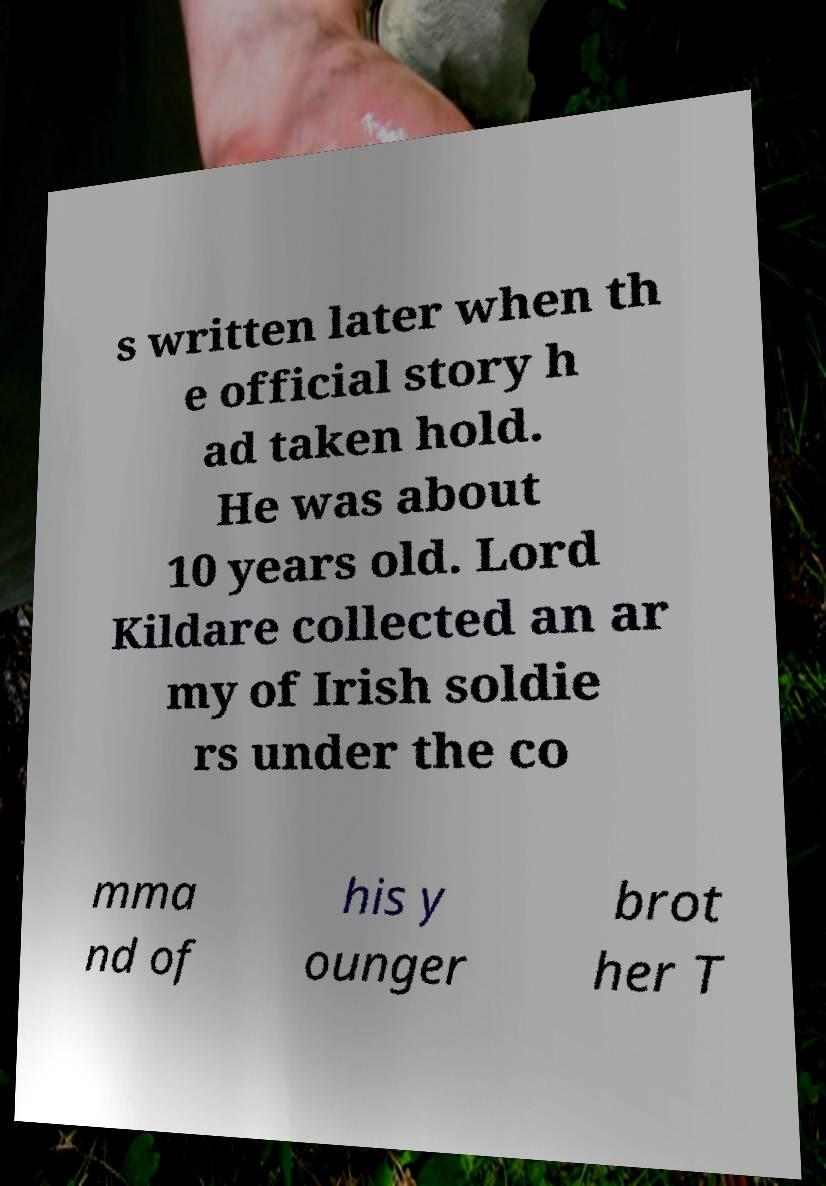What messages or text are displayed in this image? I need them in a readable, typed format. s written later when th e official story h ad taken hold. He was about 10 years old. Lord Kildare collected an ar my of Irish soldie rs under the co mma nd of his y ounger brot her T 